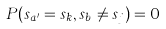Convert formula to latex. <formula><loc_0><loc_0><loc_500><loc_500>P ( s _ { a ^ { \prime } } = s _ { k } , s _ { b } \ne s _ { j } ) = 0</formula> 